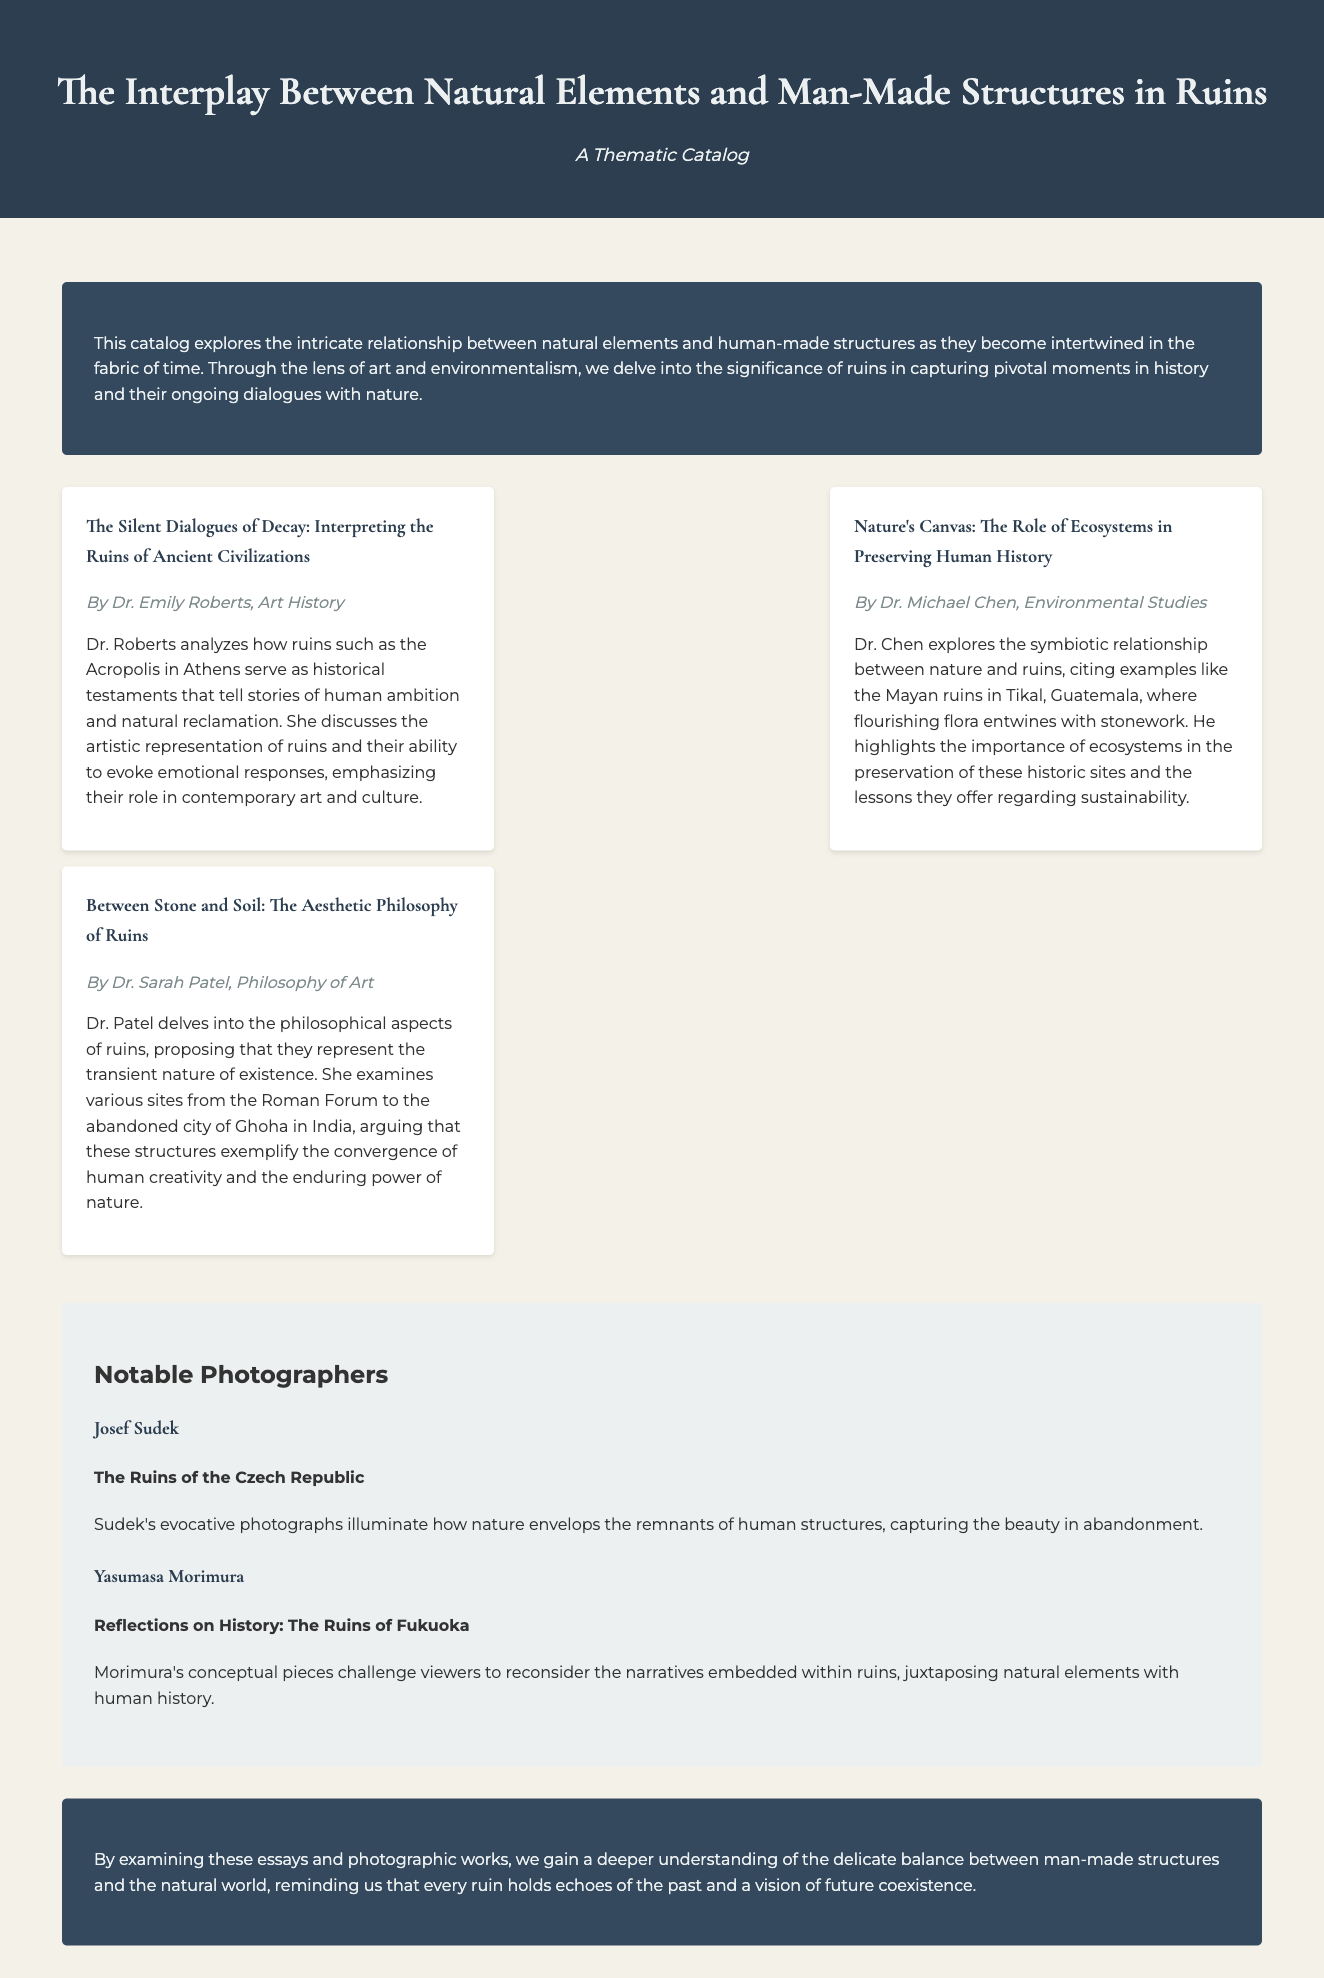What is the title of the catalog? The title of the catalog is provided in the header section of the document.
Answer: The Interplay Between Natural Elements and Man-Made Structures in Ruins Who wrote the essay on the Acropolis? The author of the essay analyzing the Acropolis is mentioned in the essay section of the document.
Answer: Dr. Emily Roberts What is the main theme of Dr. Michael Chen's essay? The theme of Dr. Chen's essay focuses on the relationship between ecosystems and historic sites, as described in the document.
Answer: Nature's role in preserving human history What notable photographer focuses on the ruins of the Czech Republic? The document lists photographers and their areas of focus specifically in the photography section.
Answer: Josef Sudek Which ancient site is discussed in Dr. Sarah Patel's essay? The essay by Dr. Patel references various sites, and this one is specifically mentioned in the document.
Answer: Roman Forum What color is the background of the introduction section? The document specifies the background color used for different sections, and this is mentioned for the introduction.
Answer: #34495e What is the subtitle of the catalog? The subtitle is listed right below the title in the header section of the document.
Answer: A Thematic Catalog Who explores the ruins of Fukuoka? The photographer and their work related to Fukuoka is mentioned in the photographers' section.
Answer: Yasumasa Morimura 